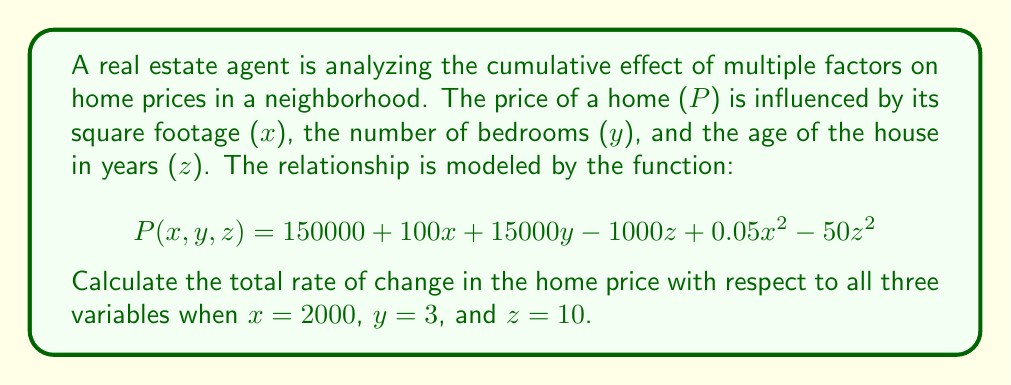Could you help me with this problem? To find the total rate of change with respect to all three variables, we need to calculate the total differential of the function $P(x,y,z)$. This involves finding the partial derivatives with respect to each variable and then evaluating them at the given points.

1. First, let's find the partial derivatives:

   $$\frac{\partial P}{\partial x} = 100 + 0.1x$$
   $$\frac{\partial P}{\partial y} = 15000$$
   $$\frac{\partial P}{\partial z} = -1000 - 100z$$

2. Now, we evaluate these partial derivatives at the given points:

   At $x = 2000$: $\frac{\partial P}{\partial x} = 100 + 0.1(2000) = 300$
   At $y = 3$: $\frac{\partial P}{\partial y} = 15000$
   At $z = 10$: $\frac{\partial P}{\partial z} = -1000 - 100(10) = -2000$

3. The total differential is given by:

   $$dP = \frac{\partial P}{\partial x}dx + \frac{\partial P}{\partial y}dy + \frac{\partial P}{\partial z}dz$$

4. Substituting the values we calculated:

   $$dP = 300dx + 15000dy - 2000dz$$

This expression represents the total rate of change in the home price with respect to all three variables at the given points.
Answer: $dP = 300dx + 15000dy - 2000dz$ 